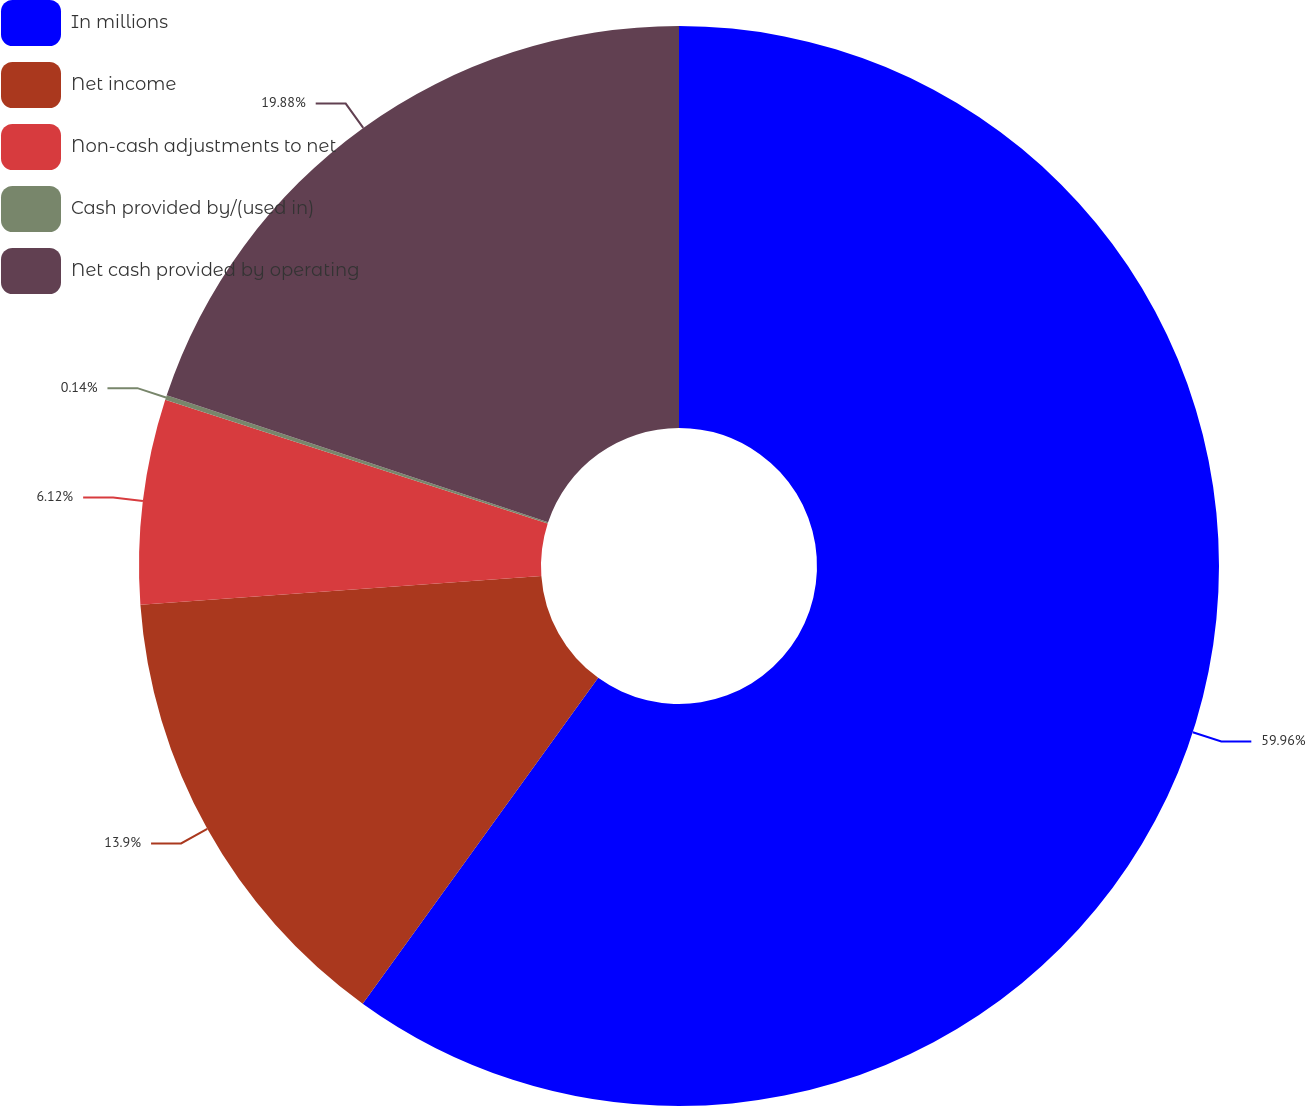Convert chart. <chart><loc_0><loc_0><loc_500><loc_500><pie_chart><fcel>In millions<fcel>Net income<fcel>Non-cash adjustments to net<fcel>Cash provided by/(used in)<fcel>Net cash provided by operating<nl><fcel>59.96%<fcel>13.9%<fcel>6.12%<fcel>0.14%<fcel>19.88%<nl></chart> 